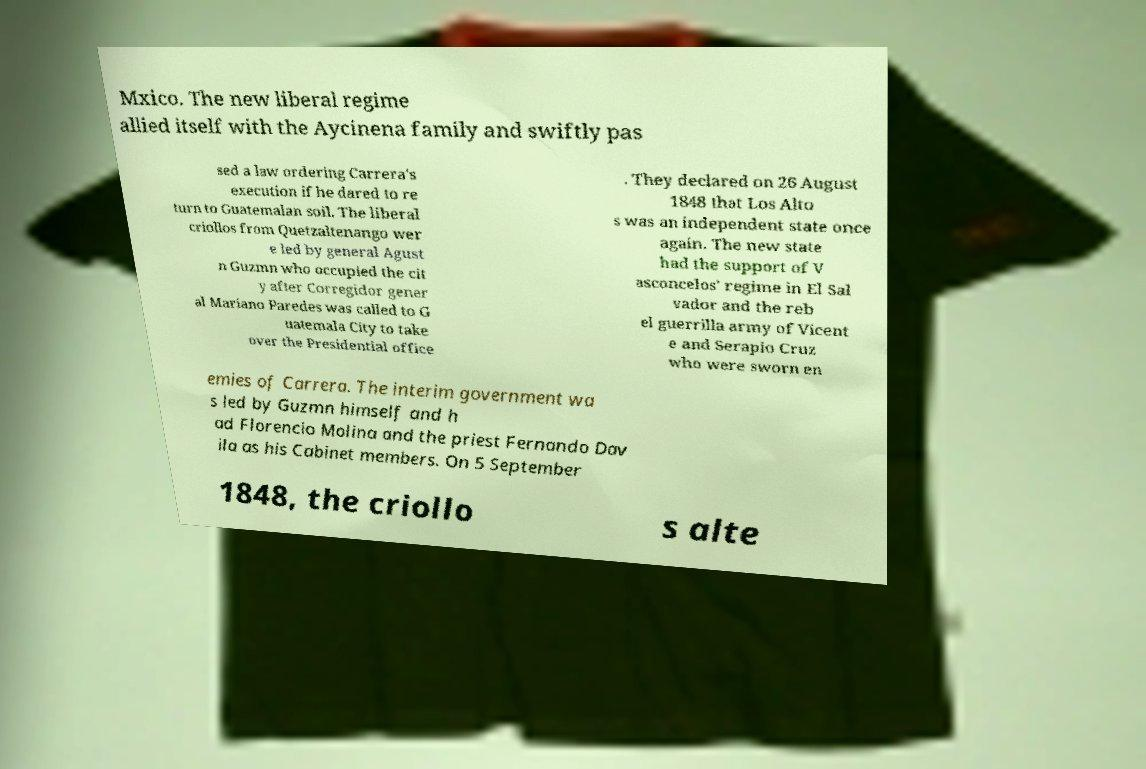Could you extract and type out the text from this image? Mxico. The new liberal regime allied itself with the Aycinena family and swiftly pas sed a law ordering Carrera's execution if he dared to re turn to Guatemalan soil. The liberal criollos from Quetzaltenango wer e led by general Agust n Guzmn who occupied the cit y after Corregidor gener al Mariano Paredes was called to G uatemala City to take over the Presidential office . They declared on 26 August 1848 that Los Alto s was an independent state once again. The new state had the support of V asconcelos' regime in El Sal vador and the reb el guerrilla army of Vicent e and Serapio Cruz who were sworn en emies of Carrera. The interim government wa s led by Guzmn himself and h ad Florencio Molina and the priest Fernando Dav ila as his Cabinet members. On 5 September 1848, the criollo s alte 